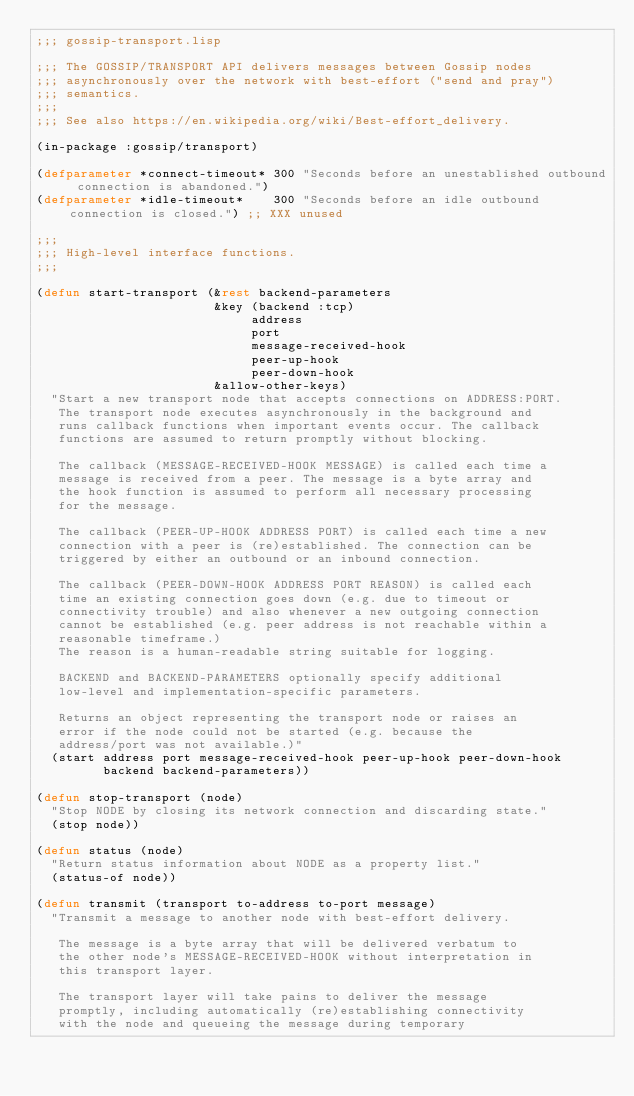<code> <loc_0><loc_0><loc_500><loc_500><_Lisp_>;;; gossip-transport.lisp

;;; The GOSSIP/TRANSPORT API delivers messages between Gossip nodes
;;; asynchronously over the network with best-effort ("send and pray")
;;; semantics.
;;;
;;; See also https://en.wikipedia.org/wiki/Best-effort_delivery.

(in-package :gossip/transport)

(defparameter *connect-timeout* 300 "Seconds before an unestablished outbound connection is abandoned.")
(defparameter *idle-timeout*    300 "Seconds before an idle outbound connection is closed.") ;; XXX unused

;;;
;;; High-level interface functions.
;;;

(defun start-transport (&rest backend-parameters
                        &key (backend :tcp)
                             address
                             port
                             message-received-hook
                             peer-up-hook
                             peer-down-hook
                        &allow-other-keys)
  "Start a new transport node that accepts connections on ADDRESS:PORT.
   The transport node executes asynchronously in the background and
   runs callback functions when important events occur. The callback
   functions are assumed to return promptly without blocking.

   The callback (MESSAGE-RECEIVED-HOOK MESSAGE) is called each time a
   message is received from a peer. The message is a byte array and
   the hook function is assumed to perform all necessary processing
   for the message.

   The callback (PEER-UP-HOOK ADDRESS PORT) is called each time a new
   connection with a peer is (re)established. The connection can be
   triggered by either an outbound or an inbound connection.

   The callback (PEER-DOWN-HOOK ADDRESS PORT REASON) is called each
   time an existing connection goes down (e.g. due to timeout or
   connectivity trouble) and also whenever a new outgoing connection
   cannot be established (e.g. peer address is not reachable within a
   reasonable timeframe.) 
   The reason is a human-readable string suitable for logging.

   BACKEND and BACKEND-PARAMETERS optionally specify additional
   low-level and implementation-specific parameters.

   Returns an object representing the transport node or raises an
   error if the node could not be started (e.g. because the
   address/port was not available.)"
  (start address port message-received-hook peer-up-hook peer-down-hook
         backend backend-parameters))

(defun stop-transport (node)
  "Stop NODE by closing its network connection and discarding state."
  (stop node))

(defun status (node)
  "Return status information about NODE as a property list."
  (status-of node))

(defun transmit (transport to-address to-port message)
  "Transmit a message to another node with best-effort delivery.

   The message is a byte array that will be delivered verbatum to
   the other node's MESSAGE-RECEIVED-HOOK without interpretation in
   this transport layer.

   The transport layer will take pains to deliver the message
   promptly, including automatically (re)establishing connectivity
   with the node and queueing the message during temporary</code> 